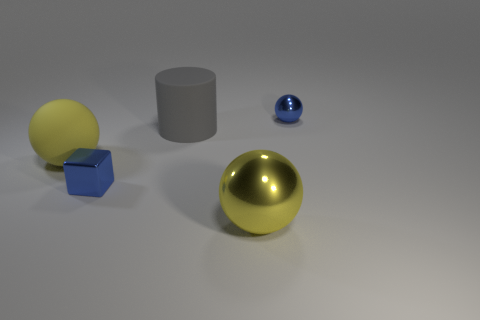What size is the metal sphere that is the same color as the cube?
Keep it short and to the point. Small. Are there any tiny red matte objects of the same shape as the big gray rubber thing?
Make the answer very short. No. There is a blue object that is behind the tiny thing that is left of the metallic thing on the right side of the yellow metallic object; how big is it?
Ensure brevity in your answer.  Small. Are there an equal number of balls that are to the left of the gray rubber thing and big yellow matte things that are on the right side of the blue metal block?
Give a very brief answer. No. There is a blue object that is the same material as the small blue block; what is its size?
Ensure brevity in your answer.  Small. What is the color of the metal cube?
Make the answer very short. Blue. What number of large metal spheres are the same color as the rubber cylinder?
Ensure brevity in your answer.  0. There is a blue block that is the same size as the blue sphere; what is its material?
Ensure brevity in your answer.  Metal. Is there a yellow sphere to the left of the sphere in front of the blue metallic block?
Provide a short and direct response. Yes. What number of other objects are there of the same color as the metal cube?
Your answer should be compact. 1. 